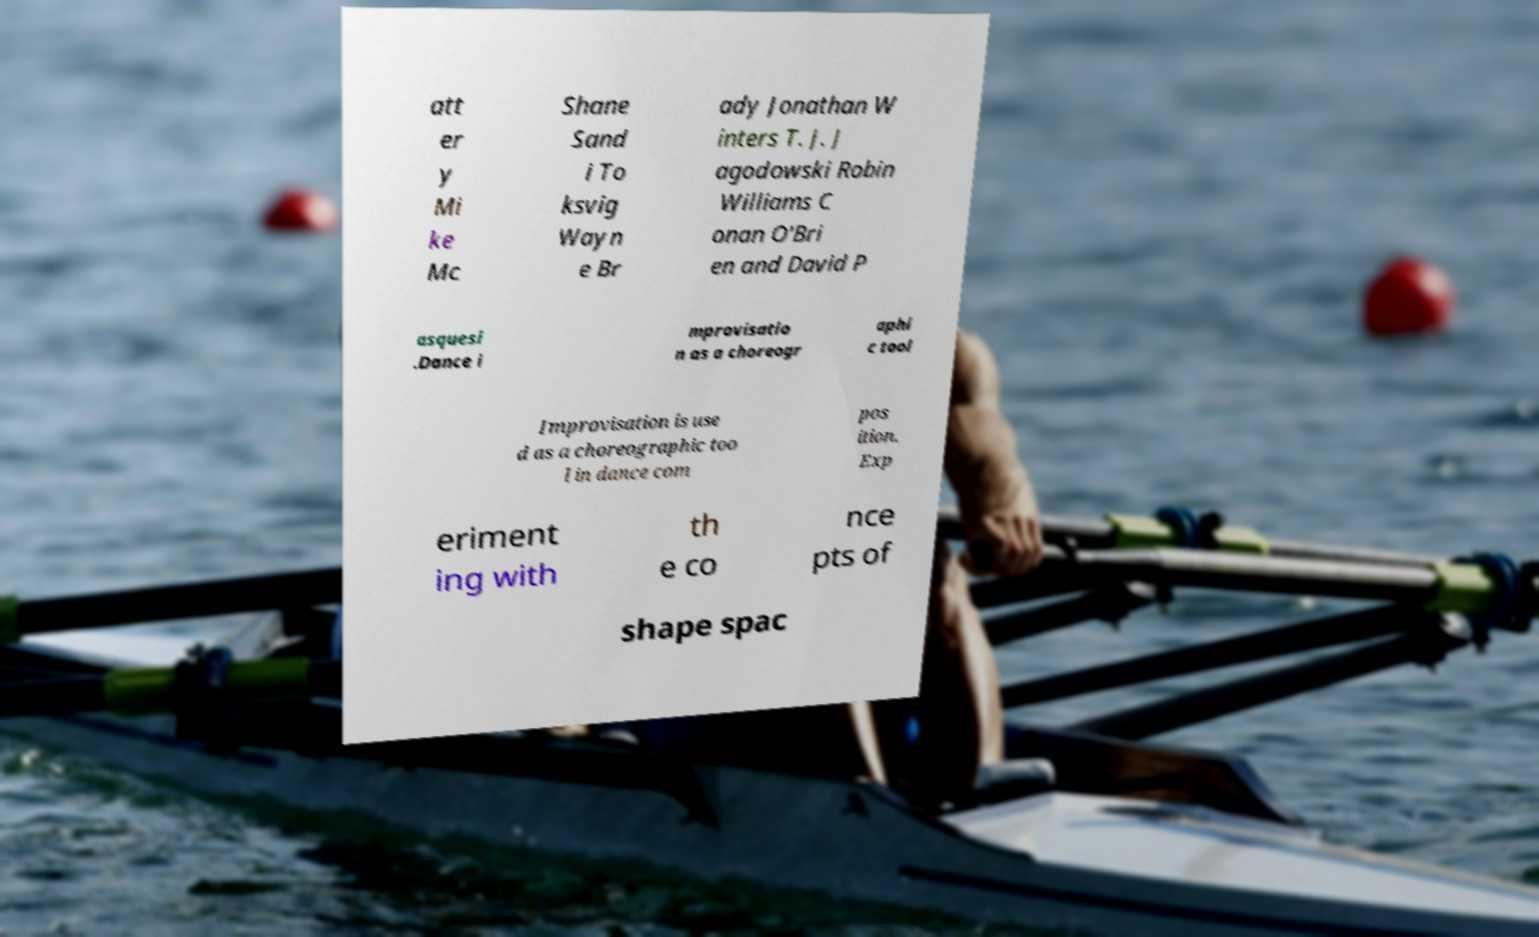I need the written content from this picture converted into text. Can you do that? att er y Mi ke Mc Shane Sand i To ksvig Wayn e Br ady Jonathan W inters T. J. J agodowski Robin Williams C onan O'Bri en and David P asquesi .Dance i mprovisatio n as a choreogr aphi c tool Improvisation is use d as a choreographic too l in dance com pos ition. Exp eriment ing with th e co nce pts of shape spac 